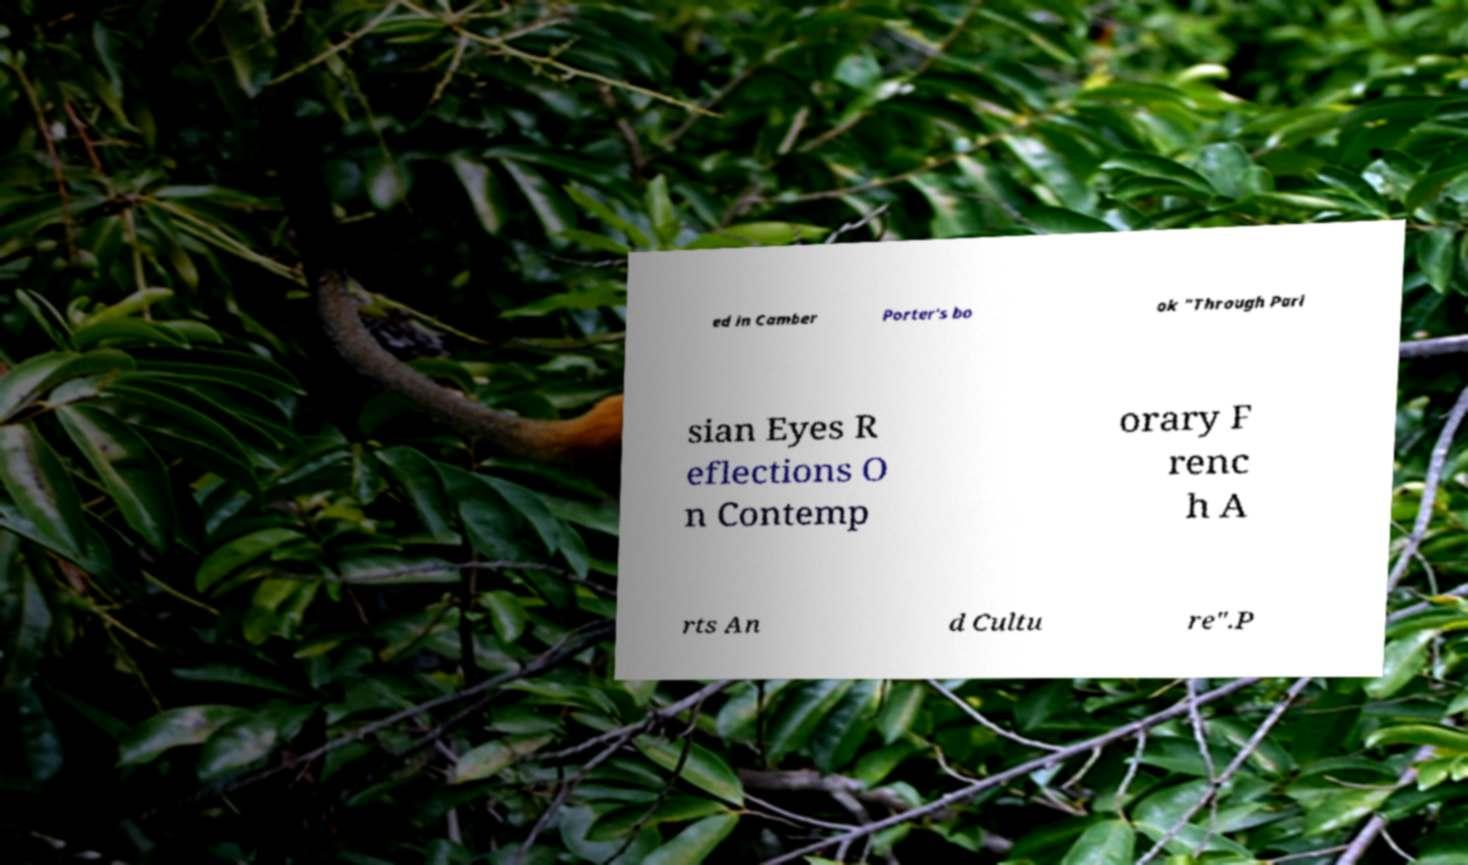Can you accurately transcribe the text from the provided image for me? ed in Camber Porter's bo ok "Through Pari sian Eyes R eflections O n Contemp orary F renc h A rts An d Cultu re".P 